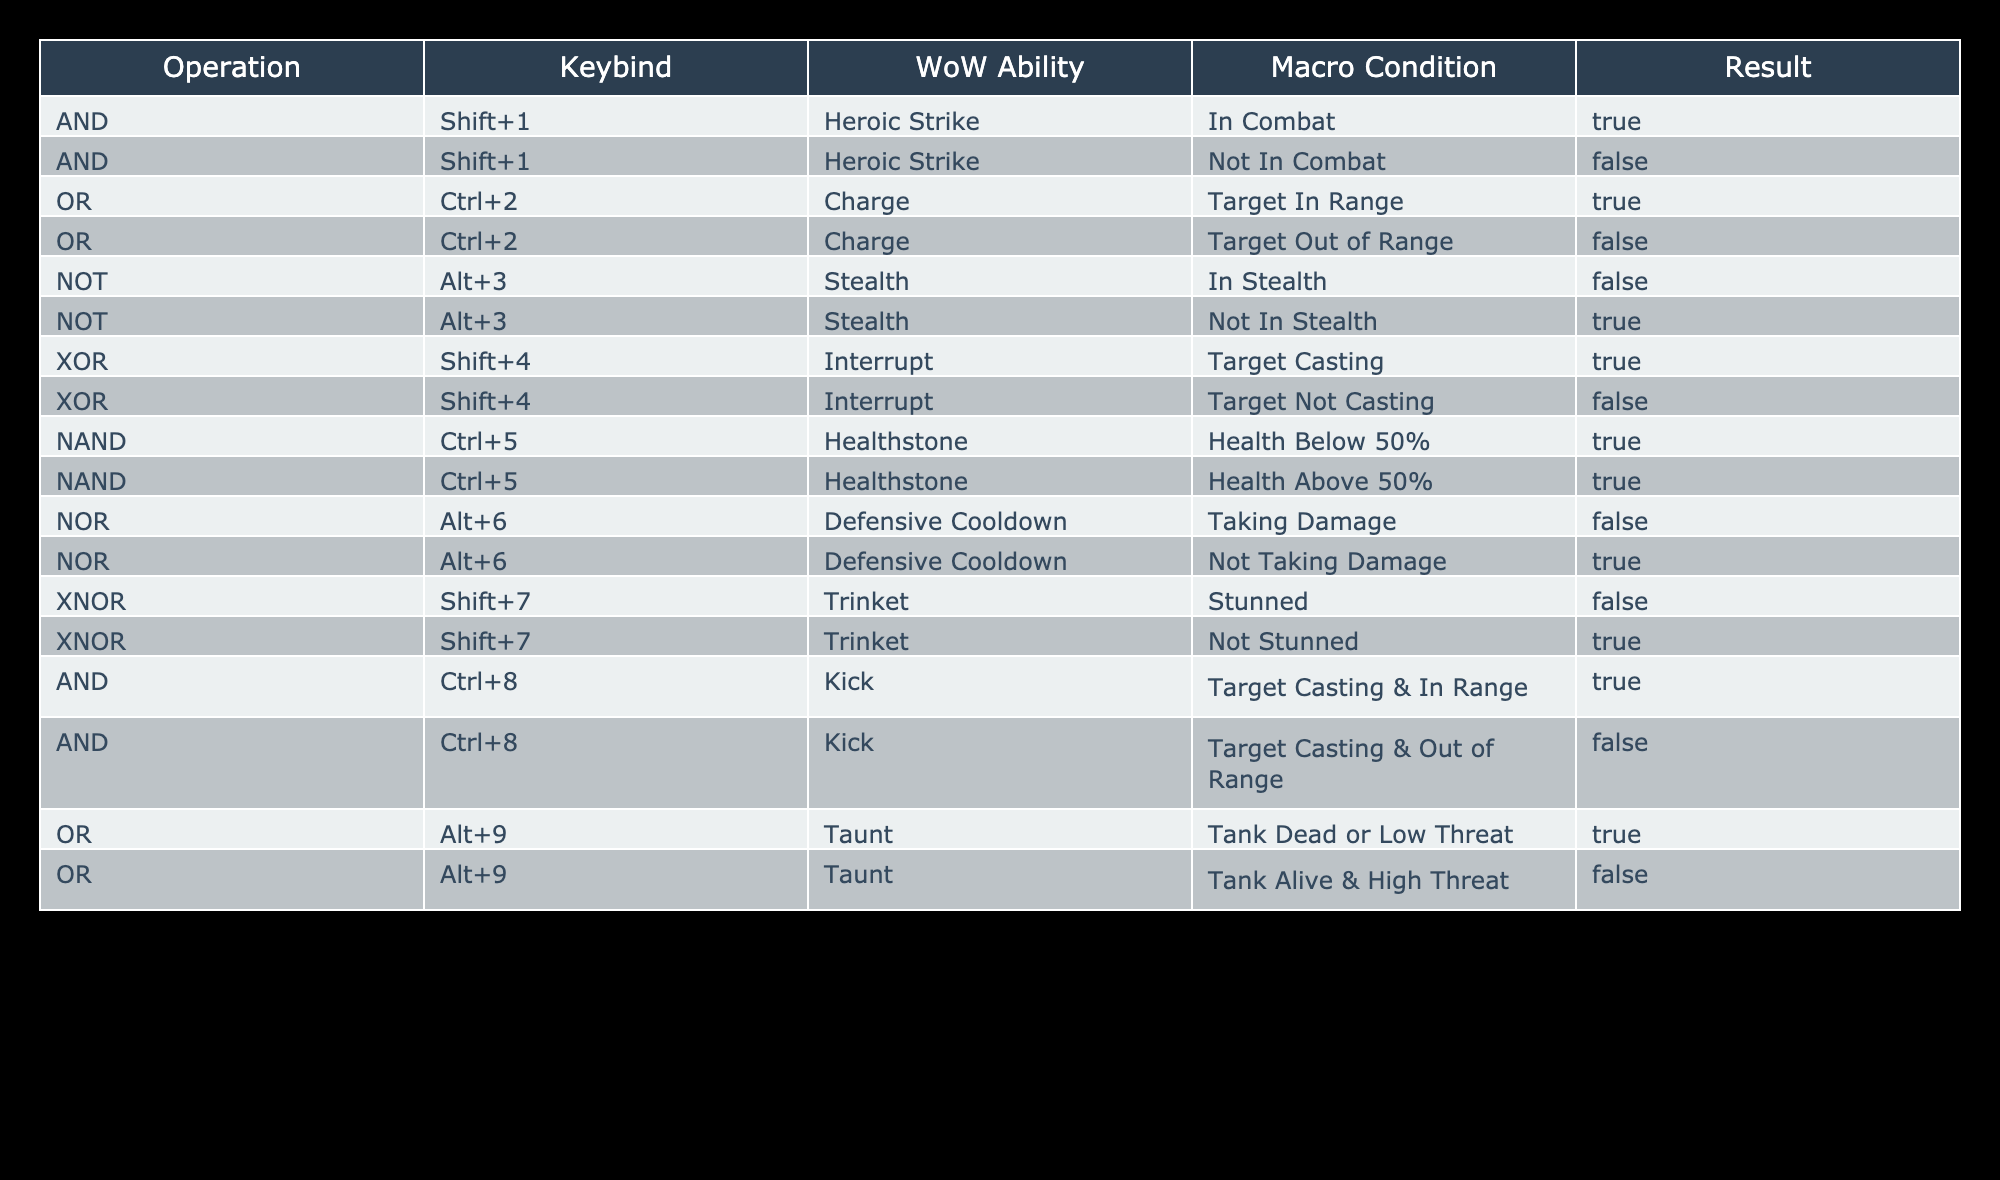What is the result of using Heroic Strike when In Combat? According to the table, the macro condition for using Heroic Strike is "In Combat," and the result for this condition is marked as True.
Answer: True What happens if you try to use Stealth when Not In Stealth? For the ability Stealth, the macro condition "Not In Stealth" is associated with a result of True, meaning you can activate it under this condition.
Answer: True Which keybind corresponds to the Taunt ability when the Tank is Alive & High Threat? The table lists the Taunt ability under the keybind Alt+9, and when the condition is "Tank Alive & High Threat," the result is False, indicating Taunt cannot be used.
Answer: False Do abilities with the NAND operation give a True result when health is above 50%? The NAND operation for Healthstone shows two conditions: one for "Health Below 50%" and one for "Health Above 50%." Both conditions give a True result, meaning the ability can always be used regardless of health.
Answer: Yes If the target is casting, can you successfully use Kick? The Kick ability has the condition "Target Casting & In Range," which gives a True result, meaning if the target is casting and you are within range, you can successfully use Kick.
Answer: True What is the result of using Defensive Cooldown while Taking Damage? The Defensive Cooldown, under the macro condition "Taking Damage," has a result of False, indicating it cannot be activated under this condition.
Answer: False What will be the outcome if Healthstone is used with Health Below 50%? The condition for using Healthstone with "Health Below 50%" results in True, so it can be successfully used if the health is below this threshold.
Answer: True How many abilities can be used if the condition is "Target In Range"? There are two abilities: Charge (Ctrl+2) and Kick (Ctrl+8), both of which can be used when the condition "Target In Range" is met. The combined result is 2 abilities.
Answer: 2 Is it possible to use the Interrupt ability when the Target is Not Casting? Based on the XOR operation for Interrupt, when the condition is "Target Not Casting," the result is False, meaning it cannot be used in this scenario.
Answer: No 